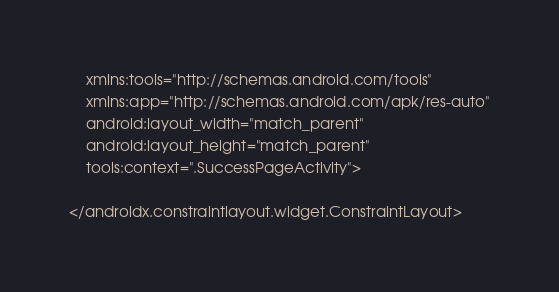<code> <loc_0><loc_0><loc_500><loc_500><_XML_>    xmlns:tools="http://schemas.android.com/tools"
    xmlns:app="http://schemas.android.com/apk/res-auto"
    android:layout_width="match_parent"
    android:layout_height="match_parent"
    tools:context=".SuccessPageActivity">

</androidx.constraintlayout.widget.ConstraintLayout></code> 